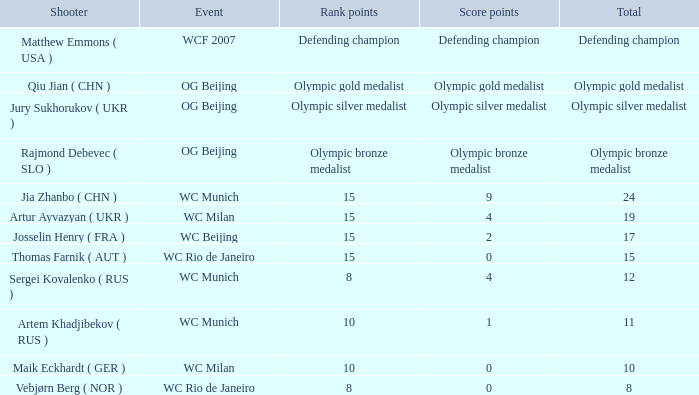With Olympic Bronze Medalist as the total what are the score points? Olympic bronze medalist. 